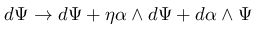<formula> <loc_0><loc_0><loc_500><loc_500>d \Psi \rightarrow d \Psi + \eta \alpha \wedge d \Psi + d \alpha \wedge \Psi</formula> 